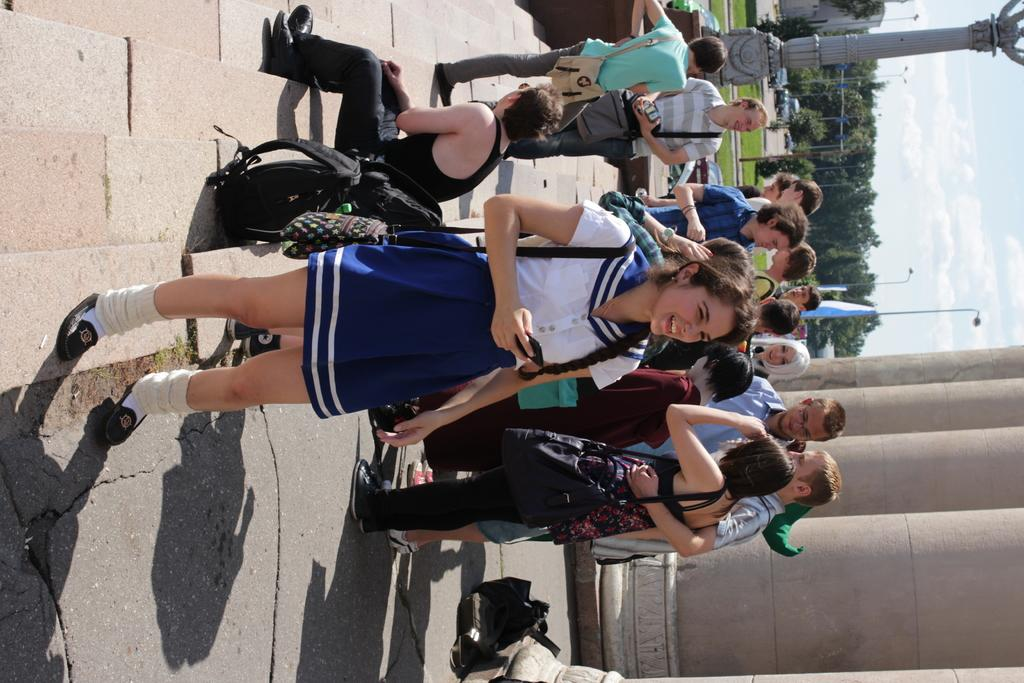How many people are in the group that is visible in the image? There is a group of people in the image, but the exact number is not specified. What are some people in the group wearing? Some people in the group are wearing bags. What can be seen in the background of the image? There are trees and the sky visible in the background of the image. Is there any quicksand visible in the image? No, there is no quicksand present in the image. How many marbles are being pushed by the people in the image? There are no marbles visible in the image, and the people are not pushing anything. 